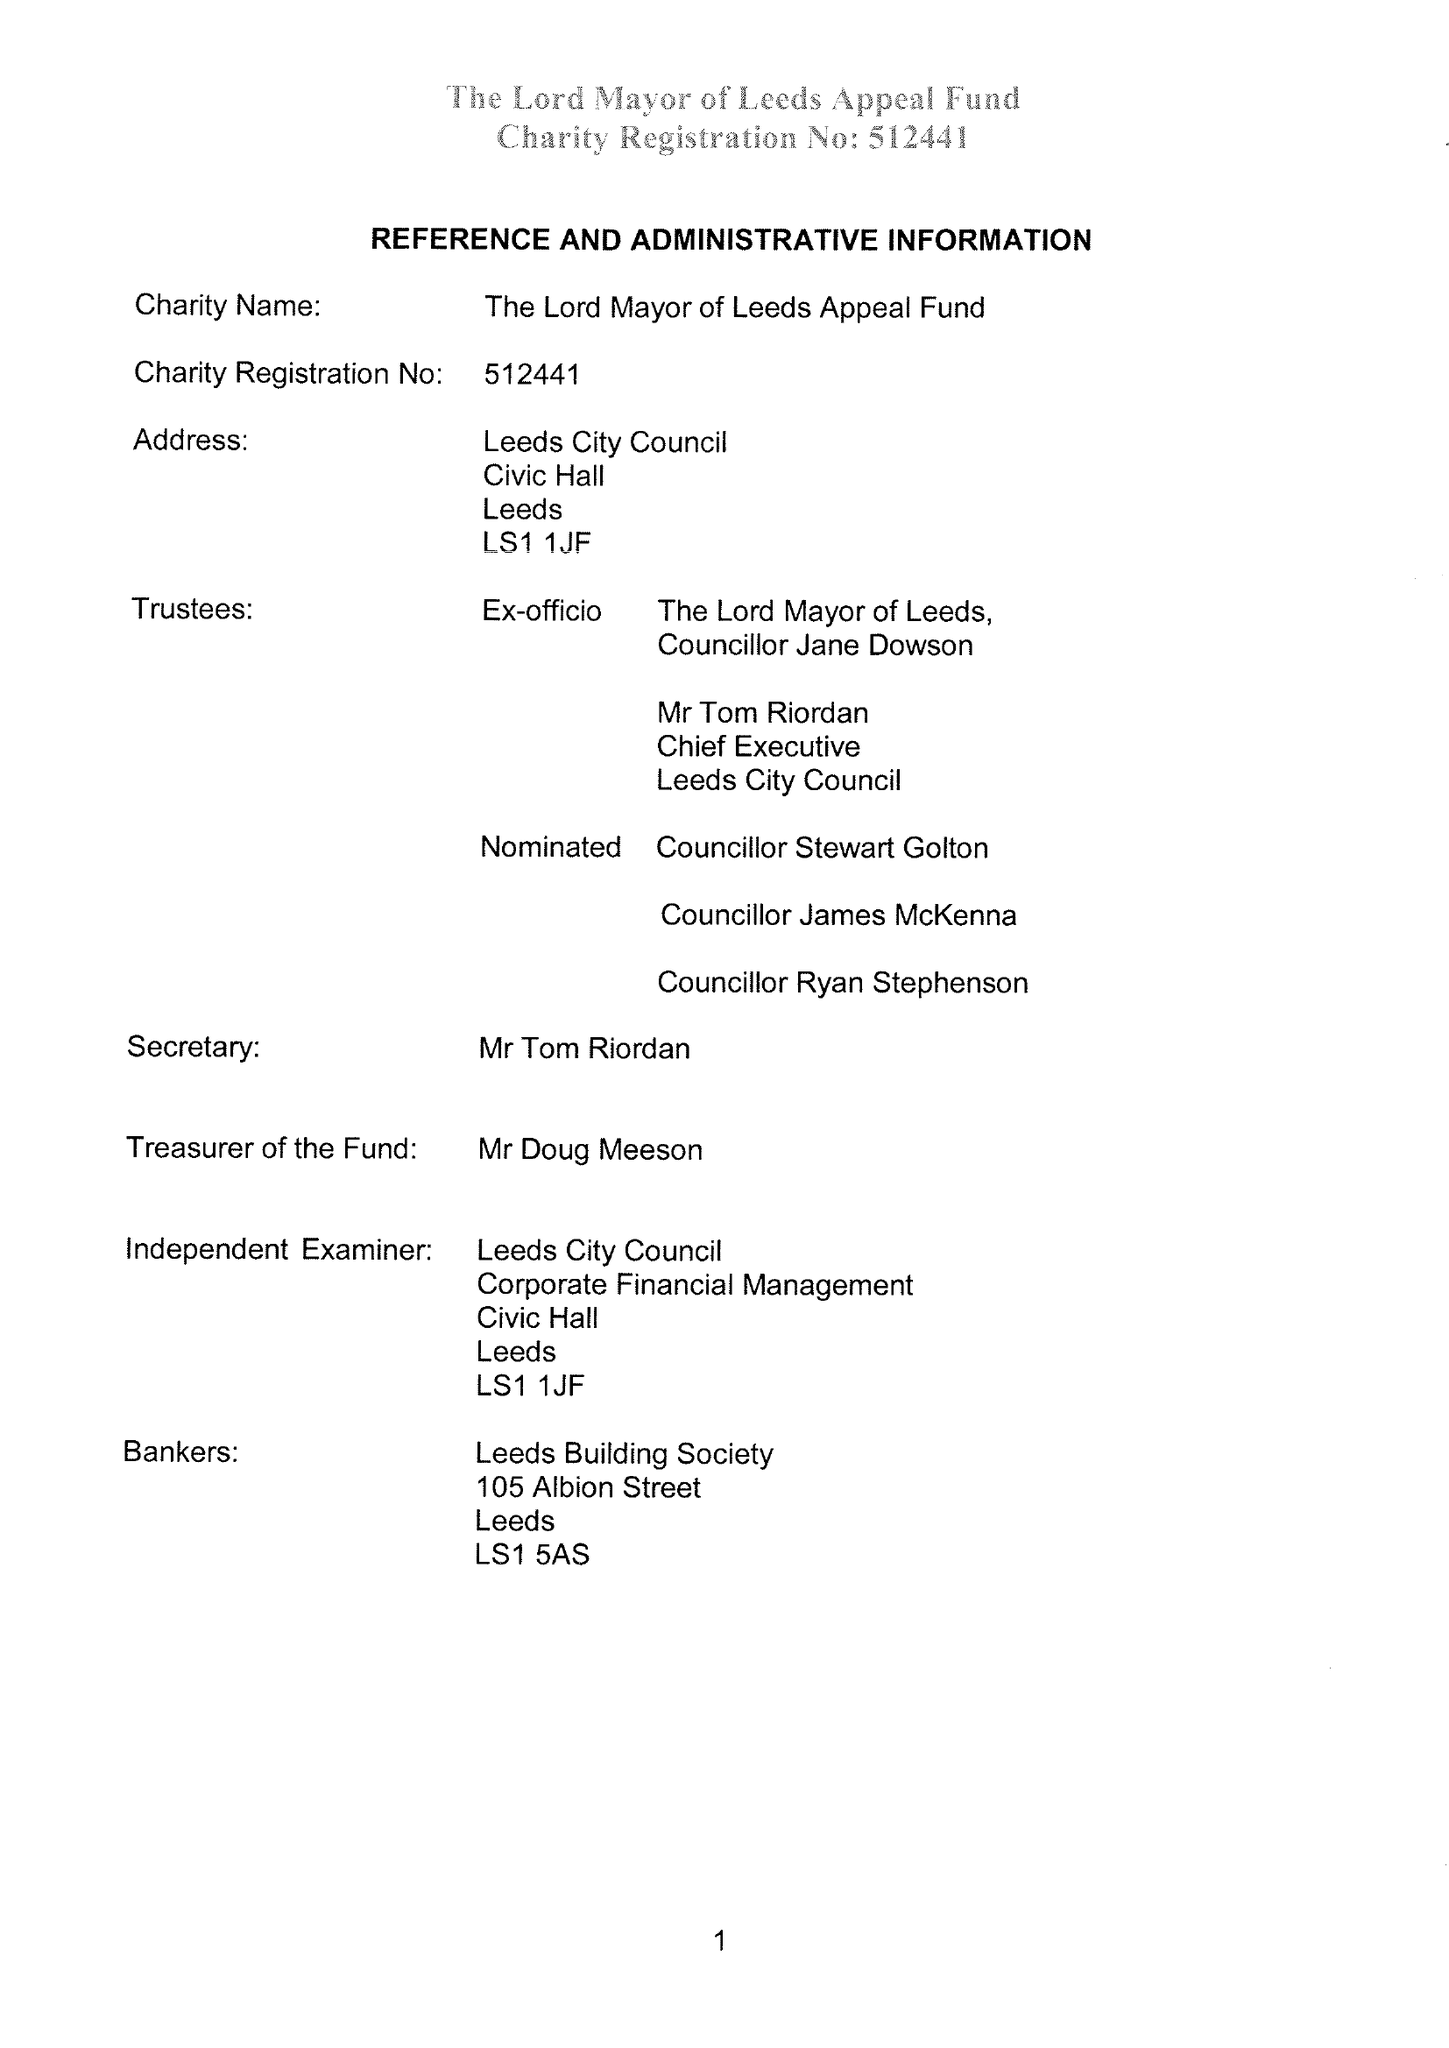What is the value for the report_date?
Answer the question using a single word or phrase. 2018-05-31 